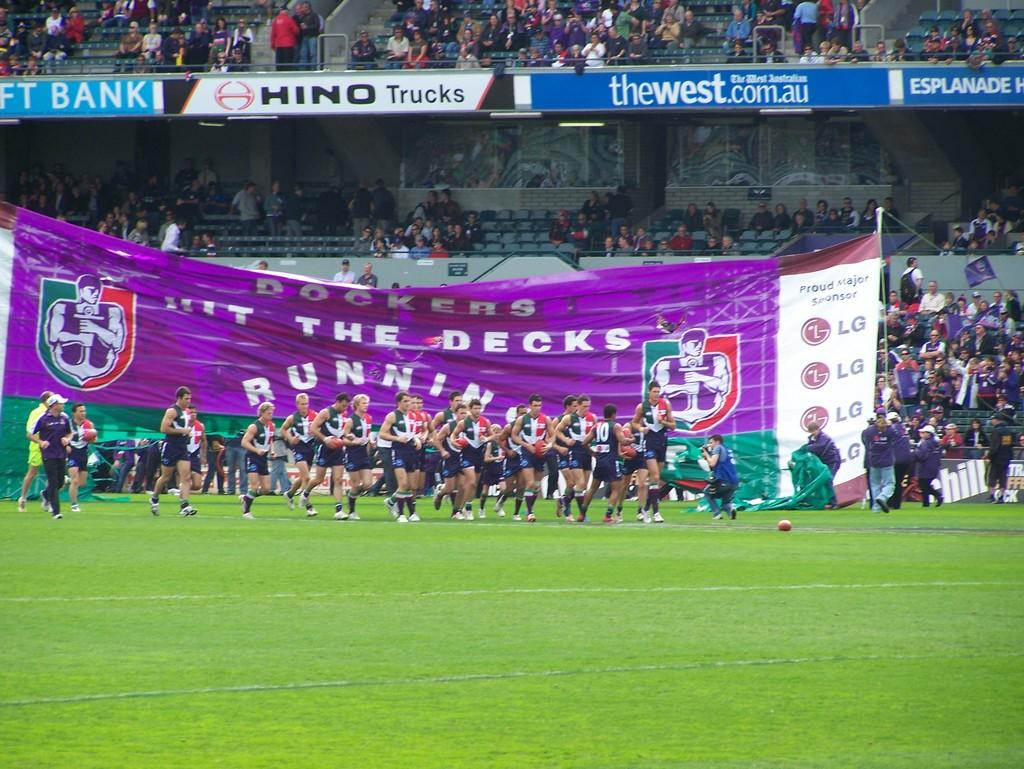<image>
Relay a brief, clear account of the picture shown. The ad in the background is for Hino Trucks 